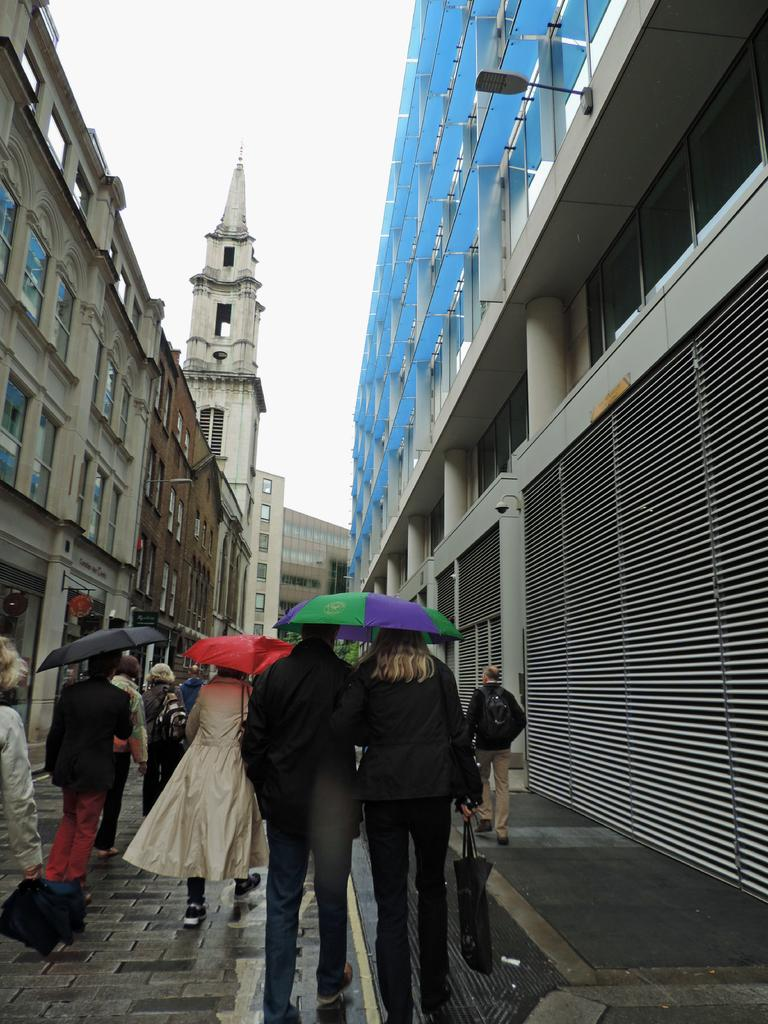What are the people in the image doing? The people in the image are walking on the footpath. What are the people holding while walking? The people are holding umbrellas. What type of structures can be seen in the image? There are buildings with windows in the image. What is the condition of the sky in the image? The sky looks cloudy in the image. What is the purpose of the street light in the image? The street light is visible in the image to provide illumination at night or during low light conditions. What type of minister is present in the image? There is no minister present in the image; it features people walking on a footpath with umbrellas, buildings with windows, a street light, and a cloudy sky. What is the profit of the street light in the image? The street light in the image is not associated with any profit; it is simply a source of illumination. 